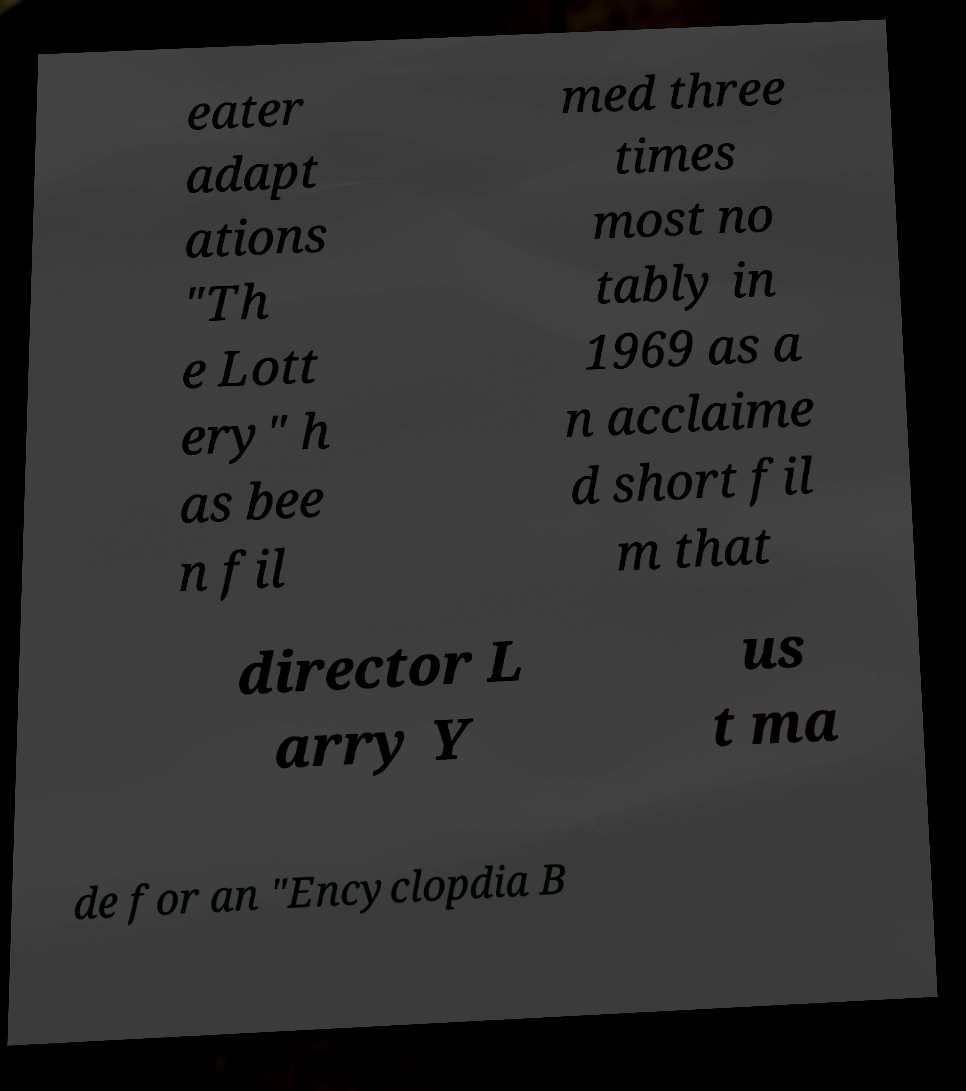Could you extract and type out the text from this image? eater adapt ations "Th e Lott ery" h as bee n fil med three times most no tably in 1969 as a n acclaime d short fil m that director L arry Y us t ma de for an "Encyclopdia B 